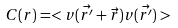Convert formula to latex. <formula><loc_0><loc_0><loc_500><loc_500>C ( r ) = < v ( \vec { r ^ { \prime } } + \vec { r } ) v ( \vec { r ^ { \prime } } ) ></formula> 